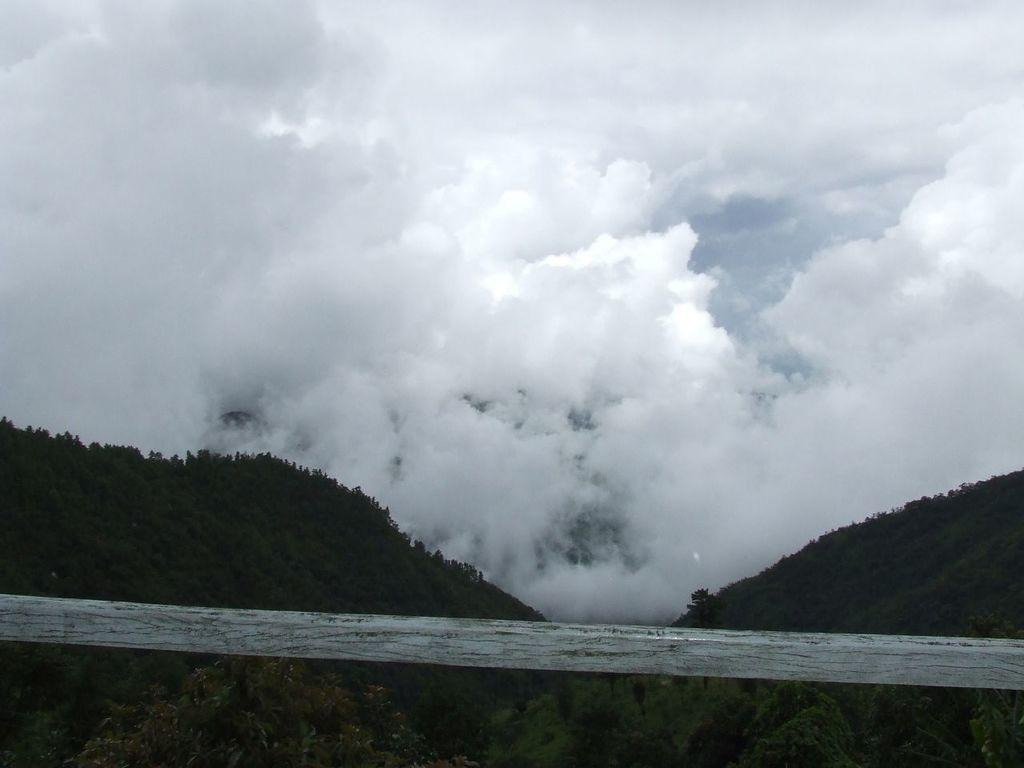What is the primary element visible in the image? There is water in the image. What can be seen in the distance in the image? There are trees, hills, and clouds in the background of the image. What type of stitch is being used to sew the clouds together in the image? There is no stitching or sewing present in the image; the clouds are natural formations in the sky. 